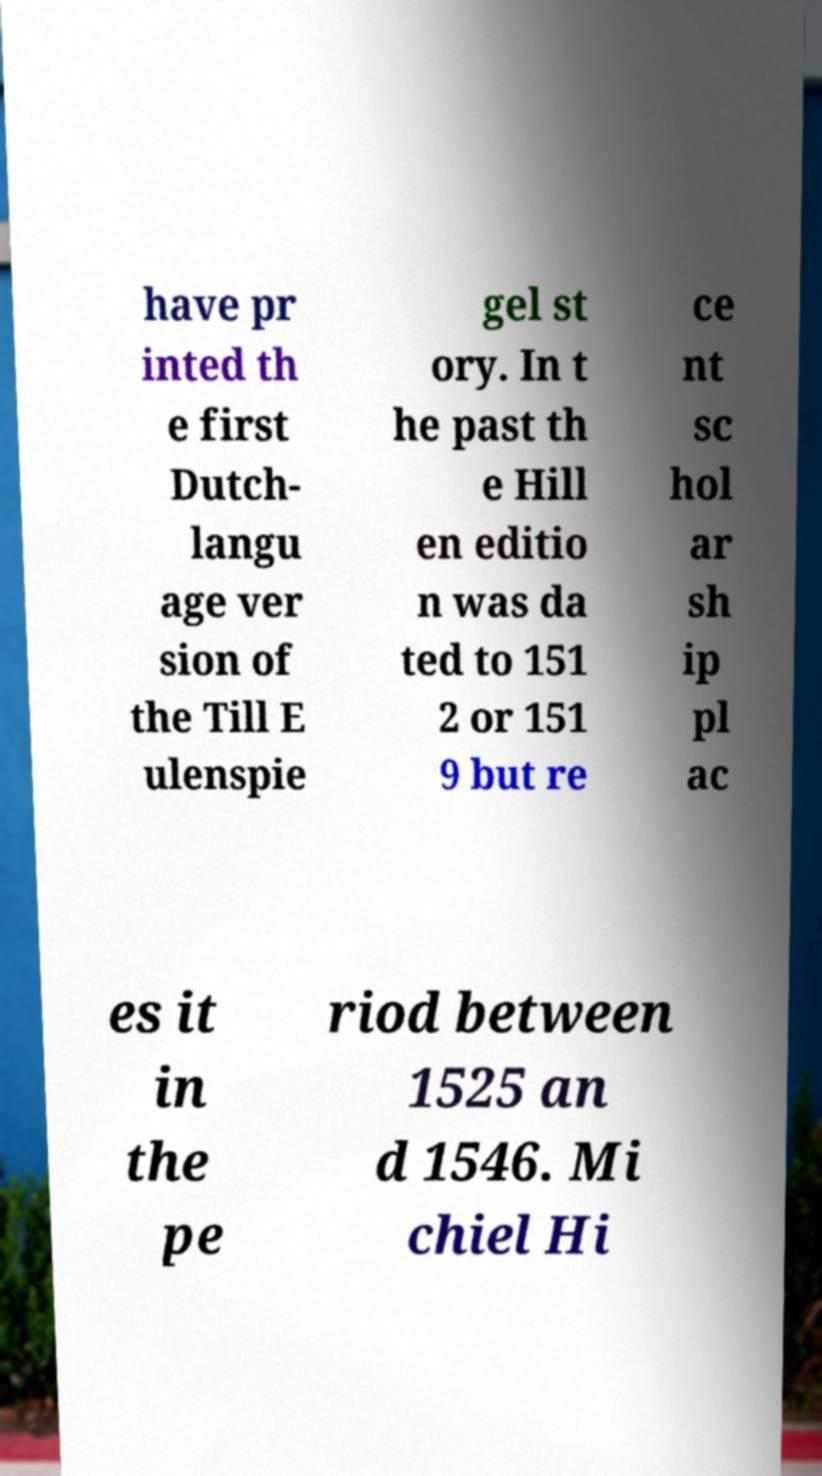For documentation purposes, I need the text within this image transcribed. Could you provide that? have pr inted th e first Dutch- langu age ver sion of the Till E ulenspie gel st ory. In t he past th e Hill en editio n was da ted to 151 2 or 151 9 but re ce nt sc hol ar sh ip pl ac es it in the pe riod between 1525 an d 1546. Mi chiel Hi 